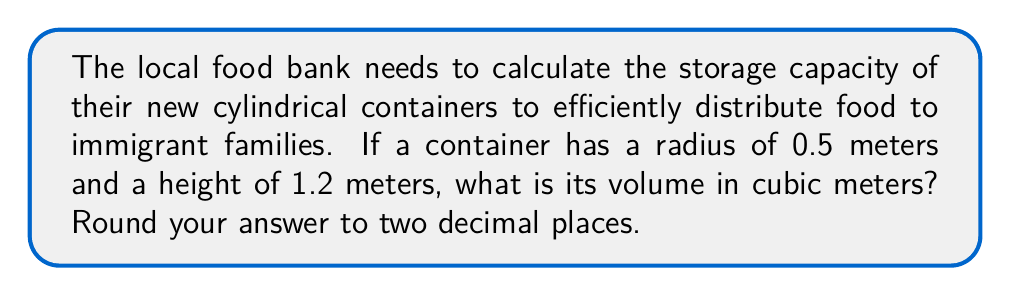Provide a solution to this math problem. To solve this problem, we'll use the formula for the volume of a cylinder:

$$V = \pi r^2 h$$

Where:
$V$ = volume
$r$ = radius
$h$ = height

Given:
$r = 0.5$ meters
$h = 1.2$ meters

Let's substitute these values into the formula:

$$V = \pi (0.5 \text{ m})^2 (1.2 \text{ m})$$

Simplify:
$$V = \pi (0.25 \text{ m}^2) (1.2 \text{ m})$$
$$V = 0.3\pi \text{ m}^3$$

Now, let's calculate this value:
$$V \approx 0.3 \times 3.14159 \text{ m}^3$$
$$V \approx 0.94248 \text{ m}^3$$

Rounding to two decimal places:
$$V \approx 0.94 \text{ m}^3$$
Answer: $0.94 \text{ m}^3$ 